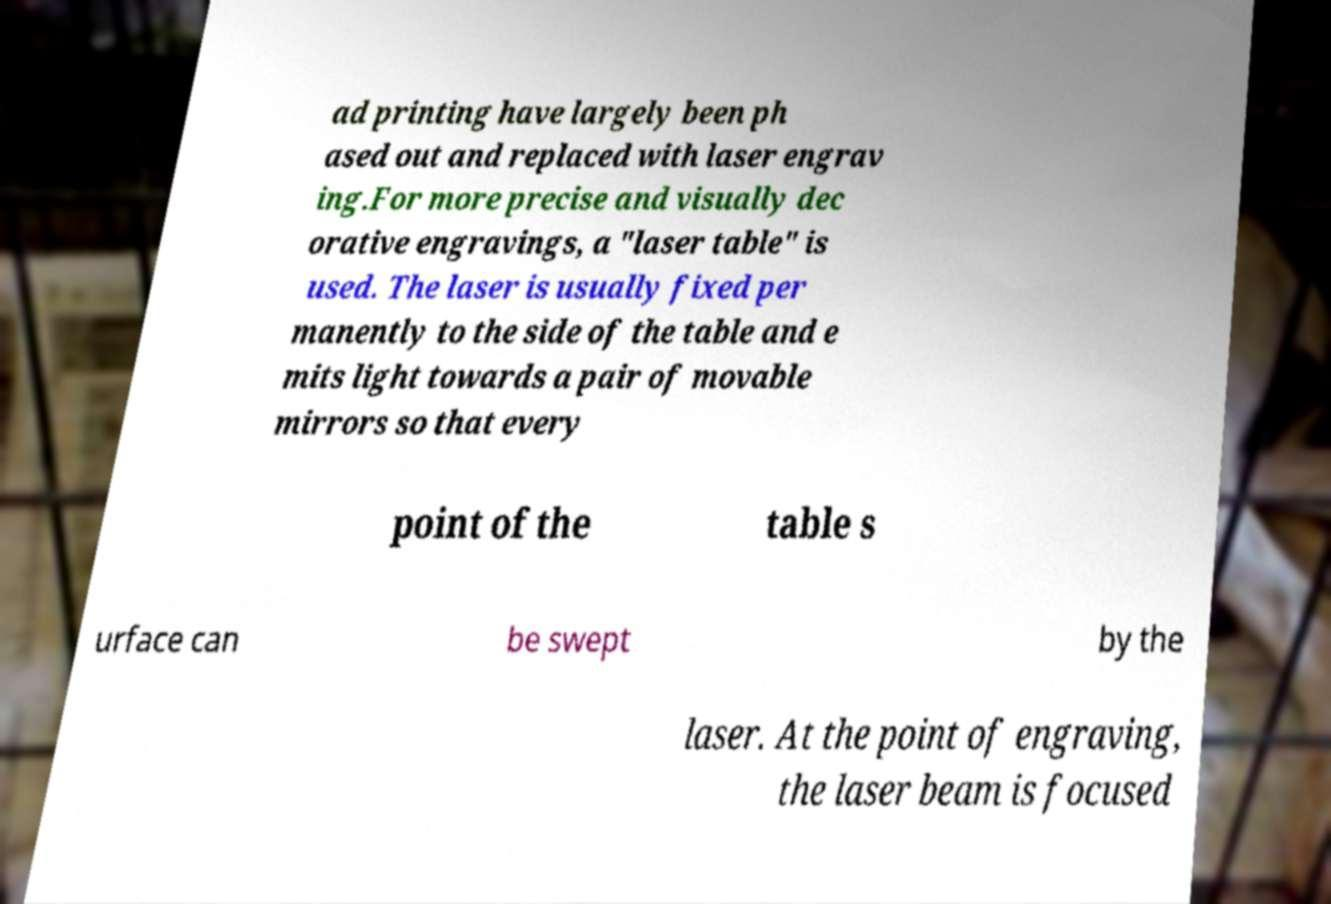I need the written content from this picture converted into text. Can you do that? ad printing have largely been ph ased out and replaced with laser engrav ing.For more precise and visually dec orative engravings, a "laser table" is used. The laser is usually fixed per manently to the side of the table and e mits light towards a pair of movable mirrors so that every point of the table s urface can be swept by the laser. At the point of engraving, the laser beam is focused 